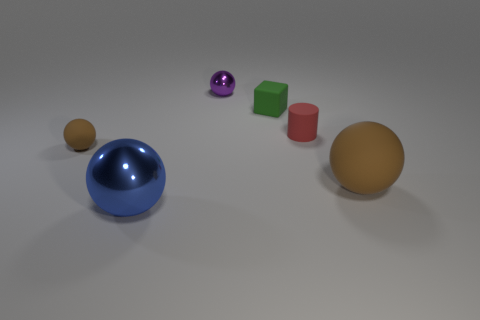Is there any other thing that has the same shape as the small red rubber thing?
Make the answer very short. No. How many objects are behind the big brown thing and to the left of the tiny red matte object?
Make the answer very short. 3. What is the shape of the big matte thing that is the same color as the tiny matte ball?
Keep it short and to the point. Sphere. What is the sphere that is both behind the large metal object and on the left side of the purple metallic object made of?
Offer a very short reply. Rubber. Is the number of small brown balls that are to the right of the blue metallic object less than the number of red matte things that are to the right of the large rubber ball?
Your answer should be very brief. No. There is a red cylinder that is the same material as the green thing; what size is it?
Make the answer very short. Small. Is there anything else that has the same color as the cylinder?
Provide a succinct answer. No. Does the red cylinder have the same material as the brown sphere that is to the right of the small red matte cylinder?
Offer a terse response. Yes. There is a large brown thing that is the same shape as the tiny purple object; what material is it?
Provide a short and direct response. Rubber. Are there any other things that are made of the same material as the tiny red cylinder?
Your answer should be compact. Yes. 